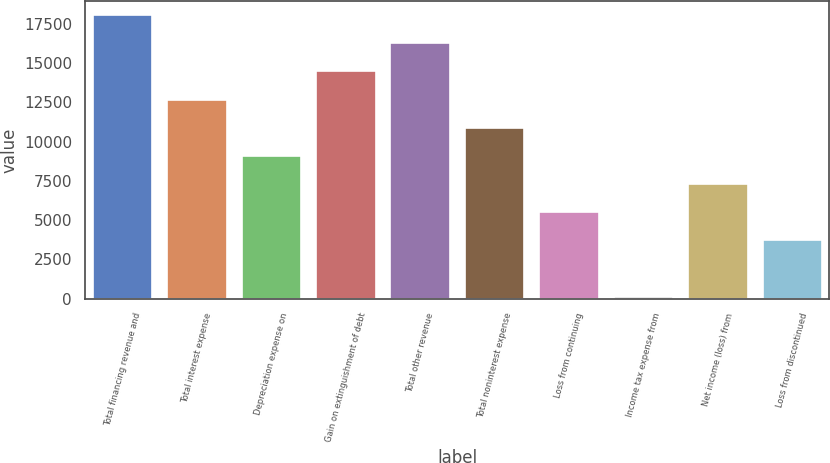<chart> <loc_0><loc_0><loc_500><loc_500><bar_chart><fcel>Total financing revenue and<fcel>Total interest expense<fcel>Depreciation expense on<fcel>Gain on extinguishment of debt<fcel>Total other revenue<fcel>Total noninterest expense<fcel>Loss from continuing<fcel>Income tax expense from<fcel>Net income (loss) from<fcel>Loss from discontinued<nl><fcel>18054<fcel>12678.6<fcel>9095<fcel>14470.4<fcel>16262.2<fcel>10886.8<fcel>5511.4<fcel>136<fcel>7303.2<fcel>3719.6<nl></chart> 